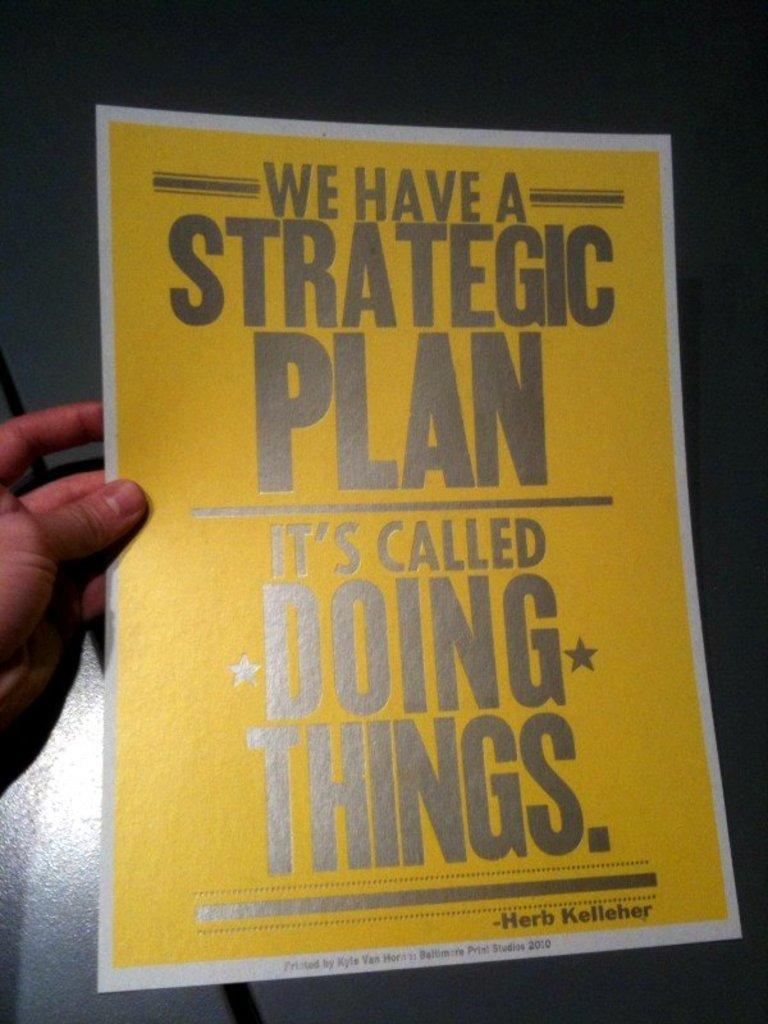Provide a one-sentence caption for the provided image. A poster talks about having a strategic plan. 